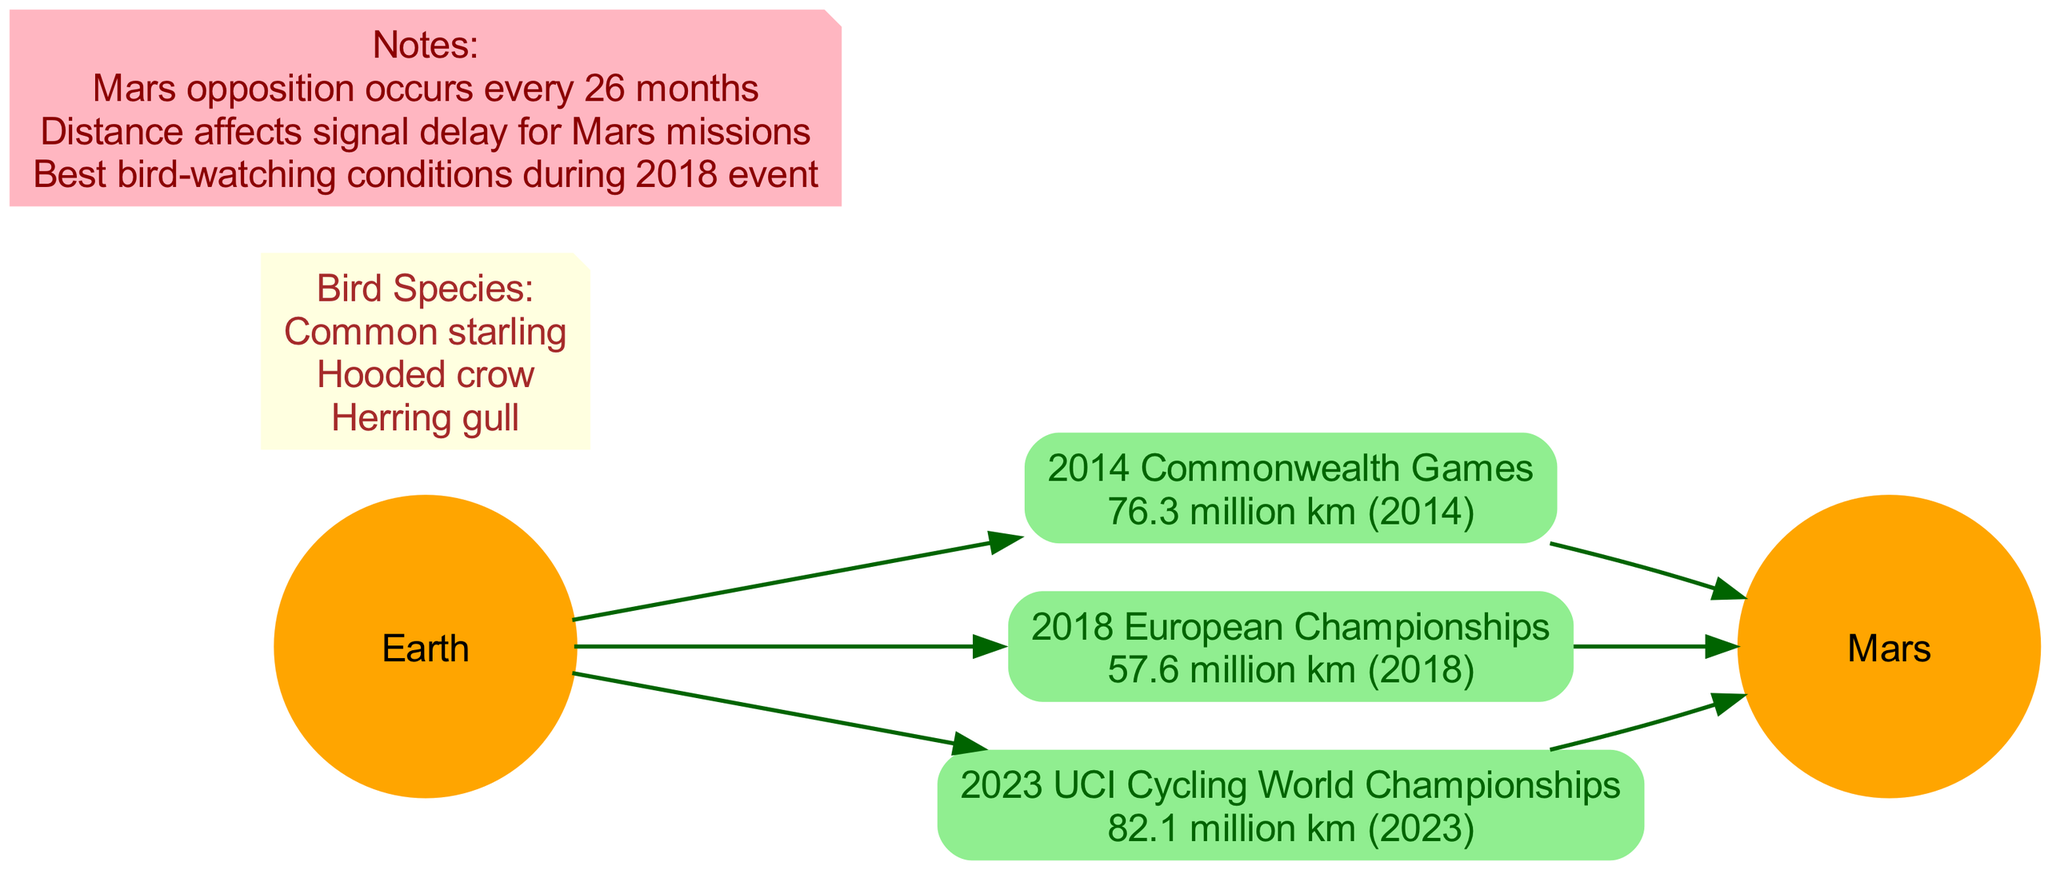What sporting event corresponds to the shortest distance to Mars? The diagram lists three events along with their respective distances from Earth to Mars. The distance for the 2018 European Championships is 57.6 million km, which is the shortest among the listed events.
Answer: 2018 European Championships How many sporting events are represented in the diagram? The diagram includes three specific sporting events: the 2014 Commonwealth Games, the 2018 European Championships, and the 2023 UCI Cycling World Championships. Counting these events gives a total of three.
Answer: 3 What is the distance from Earth to Mars during the 2023 UCI Cycling World Championships? Referring to the event node for the 2023 UCI Cycling World Championships, the distance listed is 82.1 million km.
Answer: 82.1 million km Which bird species is mentioned in relation to the best bird-watching conditions? In the notes section, it states that the best bird-watching conditions occurred during the 2018 event. The corresponding bird species visible during that time includes the common starling, hooded crow, and herring gull.
Answer: Common starling What is the relationship between Earth and Mars in the diagram? The diagram shows a connection where both Earth and Mars are linked by arrows to each sporting event. This indicates a distance measurement from Earth to Mars during each event.
Answer: Linked by arrows What note explains the importance of distance for Mars missions? The note states that the distance affects signal delay for Mars missions. This information is crucial for understanding communication challenges with Mars.
Answer: Distance affects signal delay What is the distance to Mars during the 2014 Commonwealth Games? Looking at the distance node connected to the 2014 Commonwealth Games event, it states that the distance is 76.3 million km.
Answer: 76.3 million km Which sporting event is illustrated as having the longest distance to Mars? By comparing the distances provided in the diagram, the 2023 UCI Cycling World Championships has the longest distance at 82.1 million km, making it the furthest event from Mars.
Answer: 2023 UCI Cycling World Championships What celestial bodies are depicted in the diagram? The diagram specifically represents two celestial bodies: Earth and Mars, highlighted prominently within the visual.
Answer: Earth and Mars 